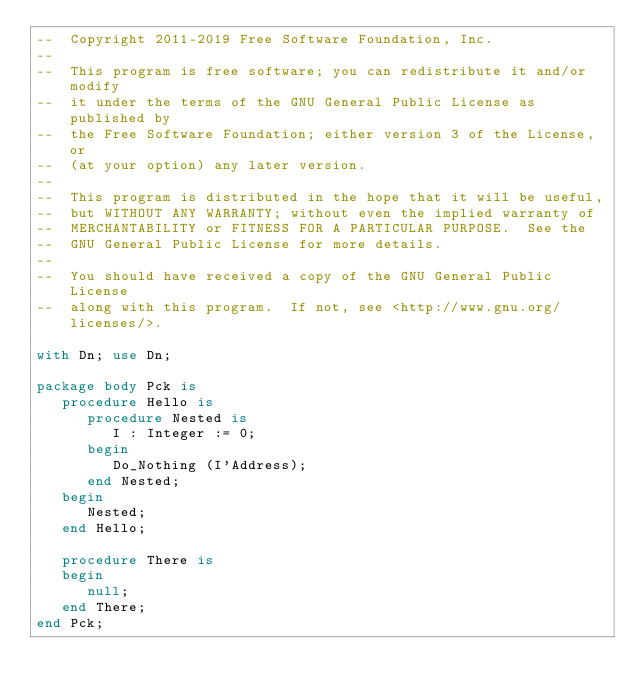Convert code to text. <code><loc_0><loc_0><loc_500><loc_500><_Ada_>--  Copyright 2011-2019 Free Software Foundation, Inc.
--
--  This program is free software; you can redistribute it and/or modify
--  it under the terms of the GNU General Public License as published by
--  the Free Software Foundation; either version 3 of the License, or
--  (at your option) any later version.
--
--  This program is distributed in the hope that it will be useful,
--  but WITHOUT ANY WARRANTY; without even the implied warranty of
--  MERCHANTABILITY or FITNESS FOR A PARTICULAR PURPOSE.  See the
--  GNU General Public License for more details.
--
--  You should have received a copy of the GNU General Public License
--  along with this program.  If not, see <http://www.gnu.org/licenses/>.

with Dn; use Dn;

package body Pck is
   procedure Hello is
      procedure Nested is
         I : Integer := 0;
      begin
         Do_Nothing (I'Address);
      end Nested;
   begin
      Nested;
   end Hello;

   procedure There is
   begin
      null;
   end There;
end Pck;


</code> 